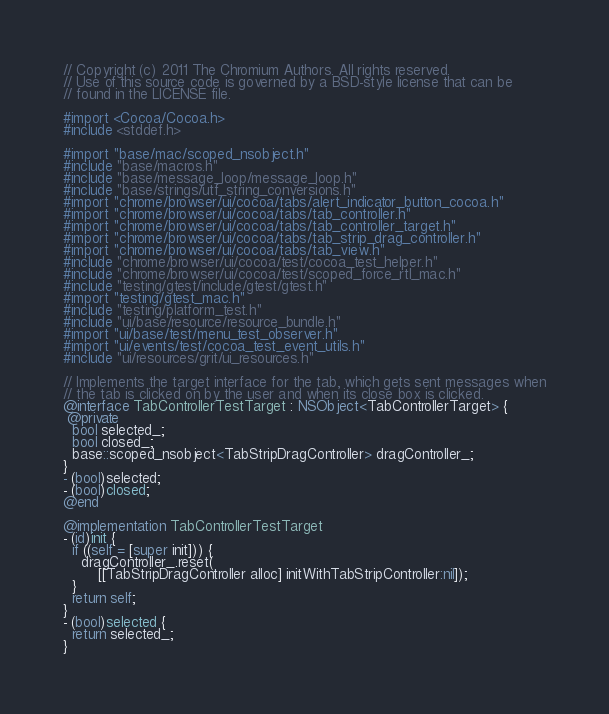<code> <loc_0><loc_0><loc_500><loc_500><_ObjectiveC_>// Copyright (c) 2011 The Chromium Authors. All rights reserved.
// Use of this source code is governed by a BSD-style license that can be
// found in the LICENSE file.

#import <Cocoa/Cocoa.h>
#include <stddef.h>

#import "base/mac/scoped_nsobject.h"
#include "base/macros.h"
#include "base/message_loop/message_loop.h"
#include "base/strings/utf_string_conversions.h"
#import "chrome/browser/ui/cocoa/tabs/alert_indicator_button_cocoa.h"
#import "chrome/browser/ui/cocoa/tabs/tab_controller.h"
#import "chrome/browser/ui/cocoa/tabs/tab_controller_target.h"
#import "chrome/browser/ui/cocoa/tabs/tab_strip_drag_controller.h"
#import "chrome/browser/ui/cocoa/tabs/tab_view.h"
#include "chrome/browser/ui/cocoa/test/cocoa_test_helper.h"
#include "chrome/browser/ui/cocoa/test/scoped_force_rtl_mac.h"
#include "testing/gtest/include/gtest/gtest.h"
#import "testing/gtest_mac.h"
#include "testing/platform_test.h"
#include "ui/base/resource/resource_bundle.h"
#import "ui/base/test/menu_test_observer.h"
#import "ui/events/test/cocoa_test_event_utils.h"
#include "ui/resources/grit/ui_resources.h"

// Implements the target interface for the tab, which gets sent messages when
// the tab is clicked on by the user and when its close box is clicked.
@interface TabControllerTestTarget : NSObject<TabControllerTarget> {
 @private
  bool selected_;
  bool closed_;
  base::scoped_nsobject<TabStripDragController> dragController_;
}
- (bool)selected;
- (bool)closed;
@end

@implementation TabControllerTestTarget
- (id)init {
  if ((self = [super init])) {
    dragController_.reset(
        [[TabStripDragController alloc] initWithTabStripController:nil]);
  }
  return self;
}
- (bool)selected {
  return selected_;
}</code> 